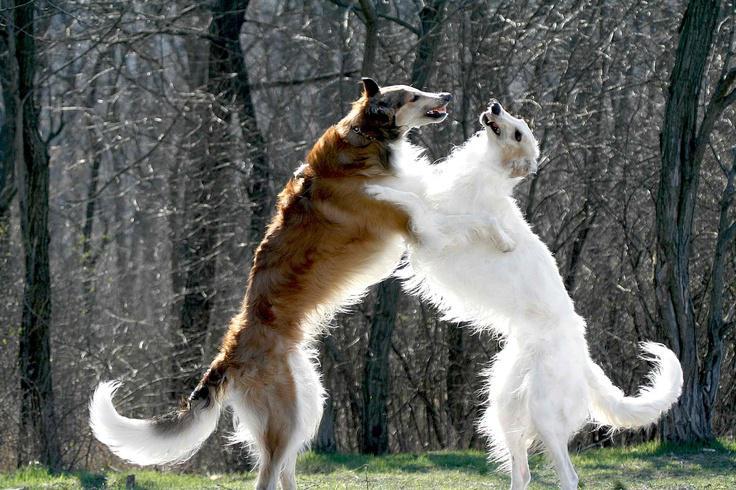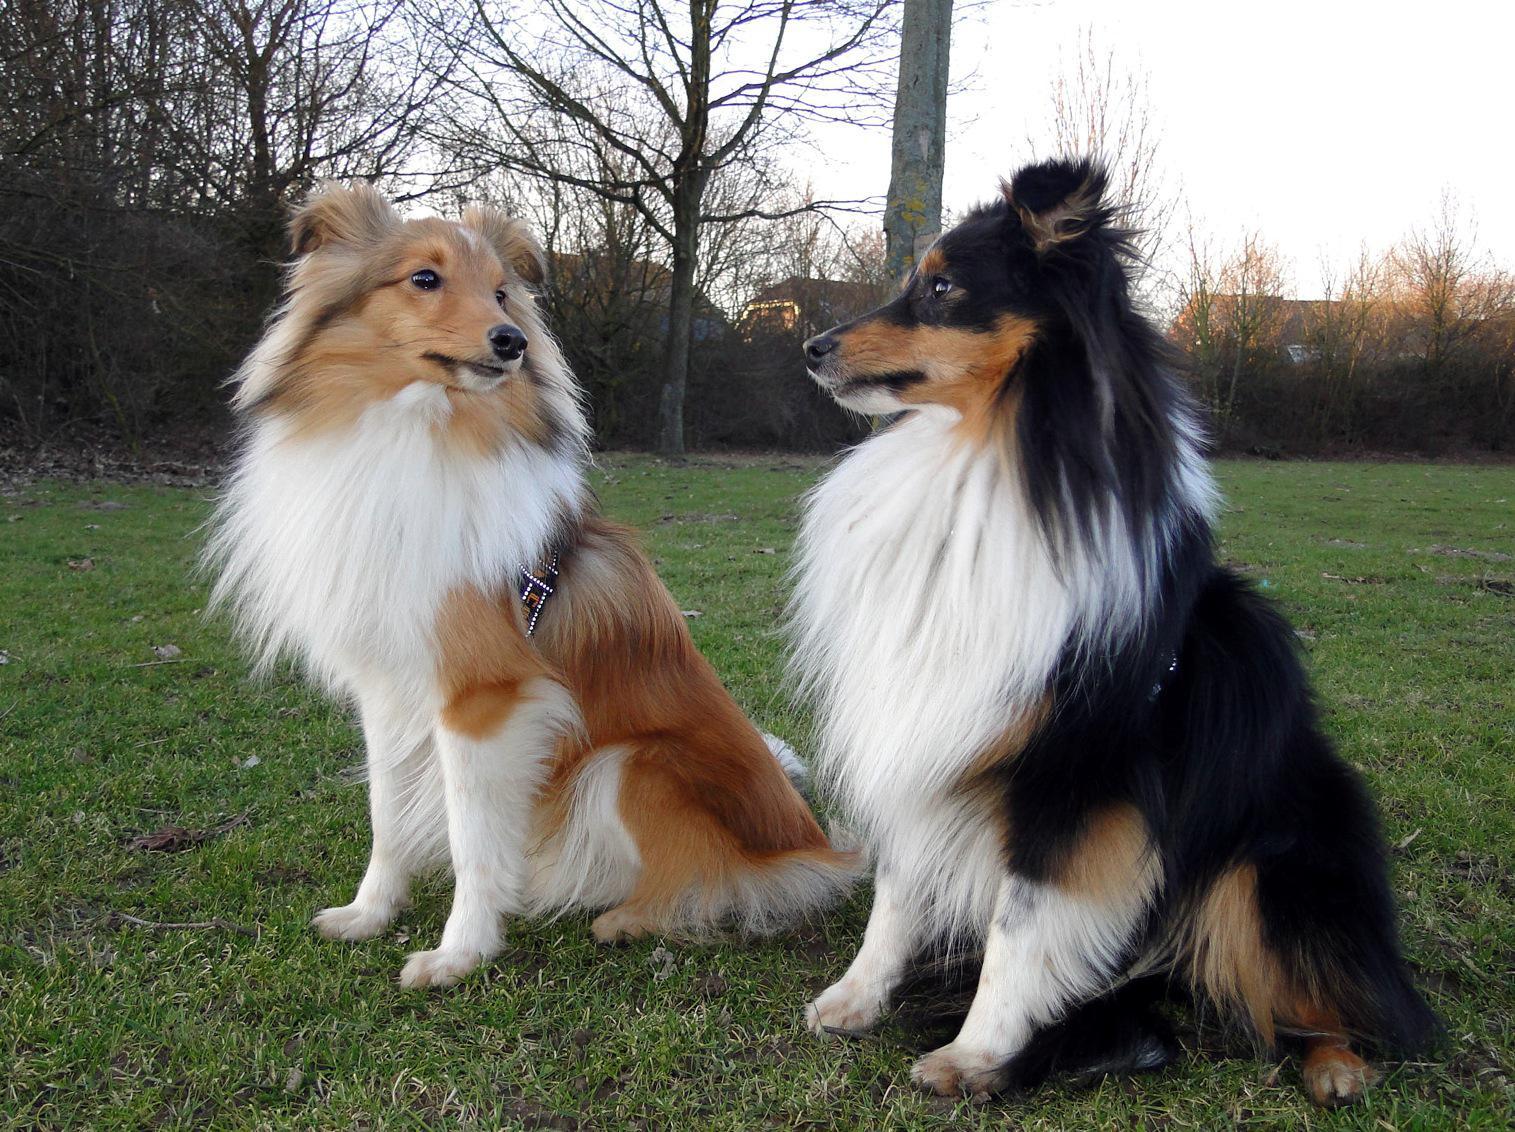The first image is the image on the left, the second image is the image on the right. Assess this claim about the two images: "There are two dogs in the left image.". Correct or not? Answer yes or no. Yes. 